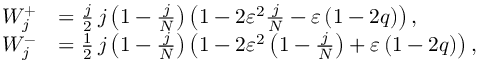Convert formula to latex. <formula><loc_0><loc_0><loc_500><loc_500>\begin{array} { r l } { W _ { j } ^ { + } } & { = \frac { j } { 2 } j \left ( 1 - \frac { j } { N } \right ) \left ( 1 - 2 \varepsilon ^ { 2 } \frac { j } { N } - \varepsilon \left ( 1 - 2 q \right ) \right ) , } \\ { W _ { j } ^ { - } } & { = \frac { 1 } { 2 } j \left ( 1 - \frac { j } { N } \right ) \left ( 1 - 2 \varepsilon ^ { 2 } \left ( 1 - \frac { j } { N } \right ) + \varepsilon \left ( 1 - 2 q \right ) \right ) , } \end{array}</formula> 